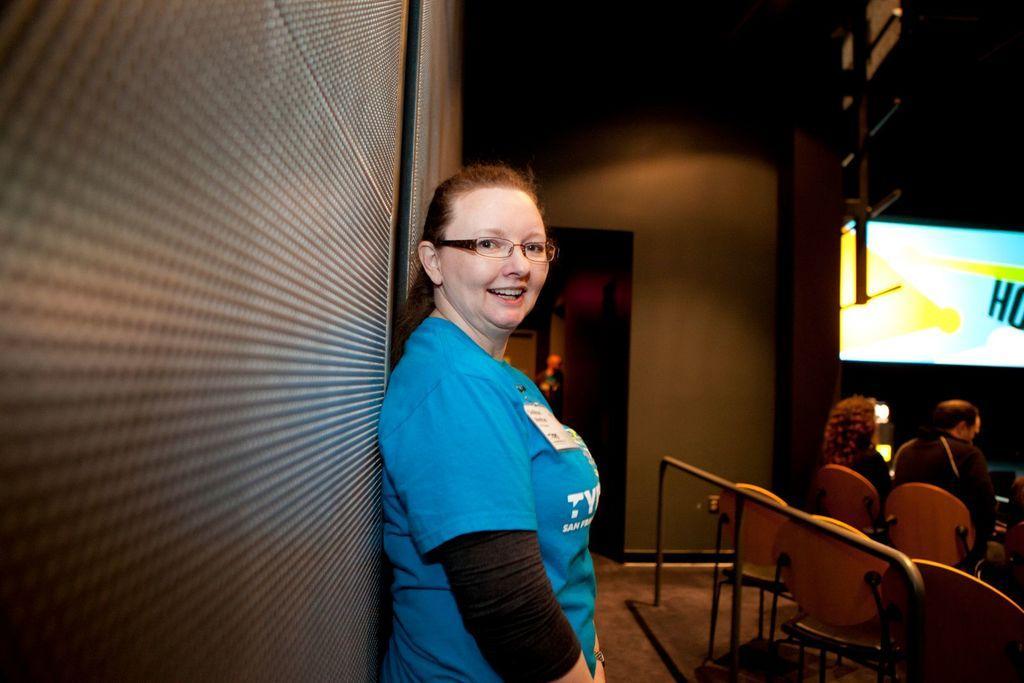Describe this image in one or two sentences. This picture shows a woman standing and she wore spectacles and we see couple of them seated on the chairs and we see few empty chairs on the back and a television with a display on it. 